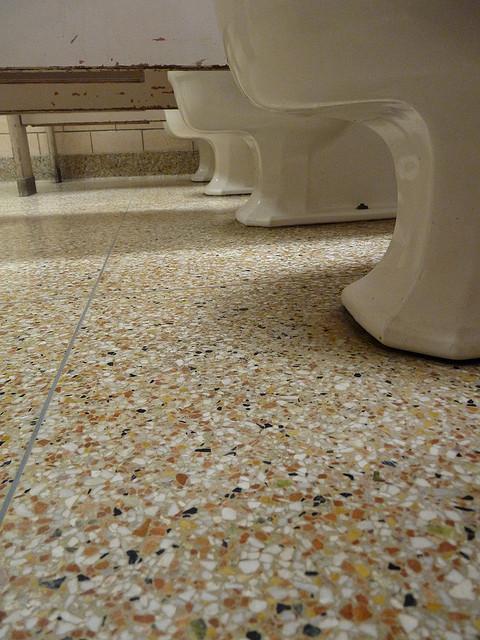How many toilets are visible?
Give a very brief answer. 4. How many toilets can you see?
Give a very brief answer. 3. 